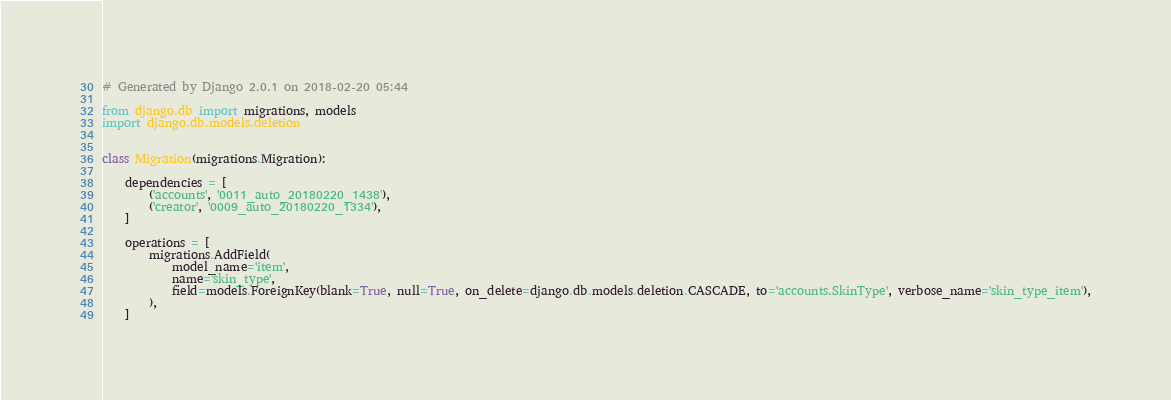Convert code to text. <code><loc_0><loc_0><loc_500><loc_500><_Python_># Generated by Django 2.0.1 on 2018-02-20 05:44

from django.db import migrations, models
import django.db.models.deletion


class Migration(migrations.Migration):

    dependencies = [
        ('accounts', '0011_auto_20180220_1438'),
        ('creator', '0009_auto_20180220_1334'),
    ]

    operations = [
        migrations.AddField(
            model_name='item',
            name='skin_type',
            field=models.ForeignKey(blank=True, null=True, on_delete=django.db.models.deletion.CASCADE, to='accounts.SkinType', verbose_name='skin_type_item'),
        ),
    ]
</code> 